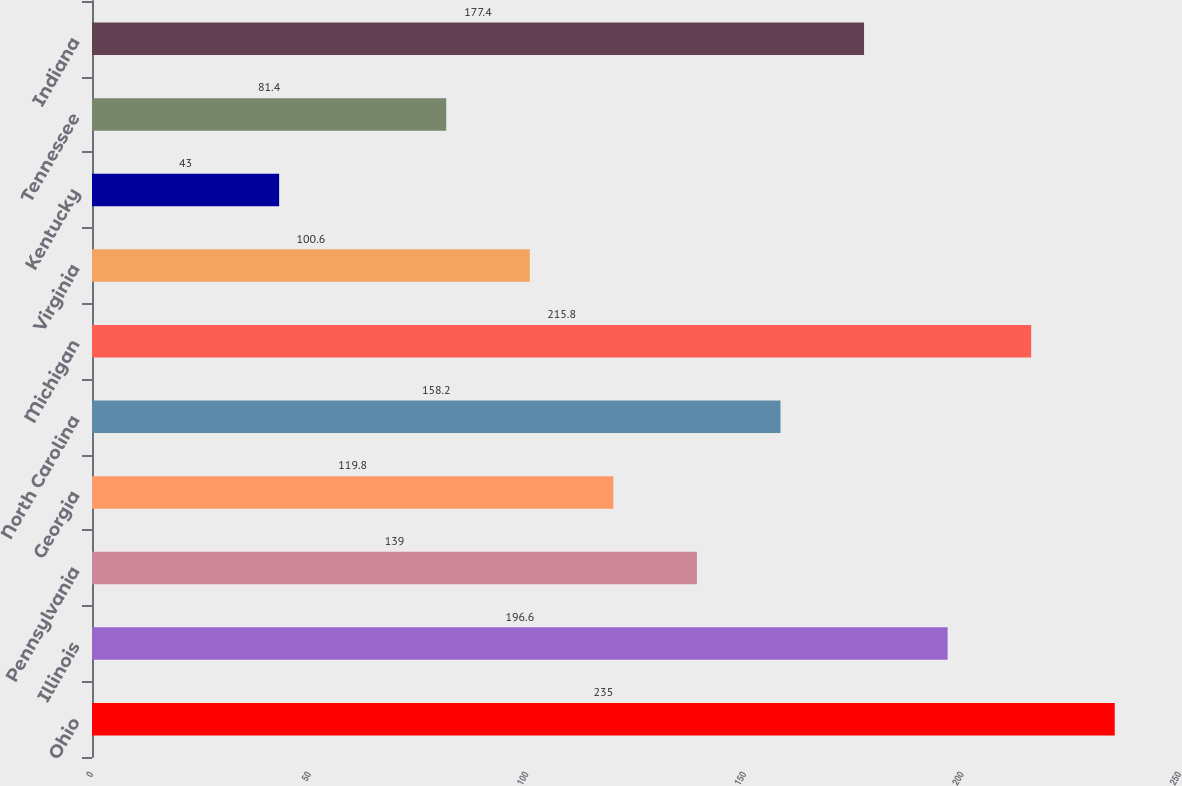Convert chart. <chart><loc_0><loc_0><loc_500><loc_500><bar_chart><fcel>Ohio<fcel>Illinois<fcel>Pennsylvania<fcel>Georgia<fcel>North Carolina<fcel>Michigan<fcel>Virginia<fcel>Kentucky<fcel>Tennessee<fcel>Indiana<nl><fcel>235<fcel>196.6<fcel>139<fcel>119.8<fcel>158.2<fcel>215.8<fcel>100.6<fcel>43<fcel>81.4<fcel>177.4<nl></chart> 